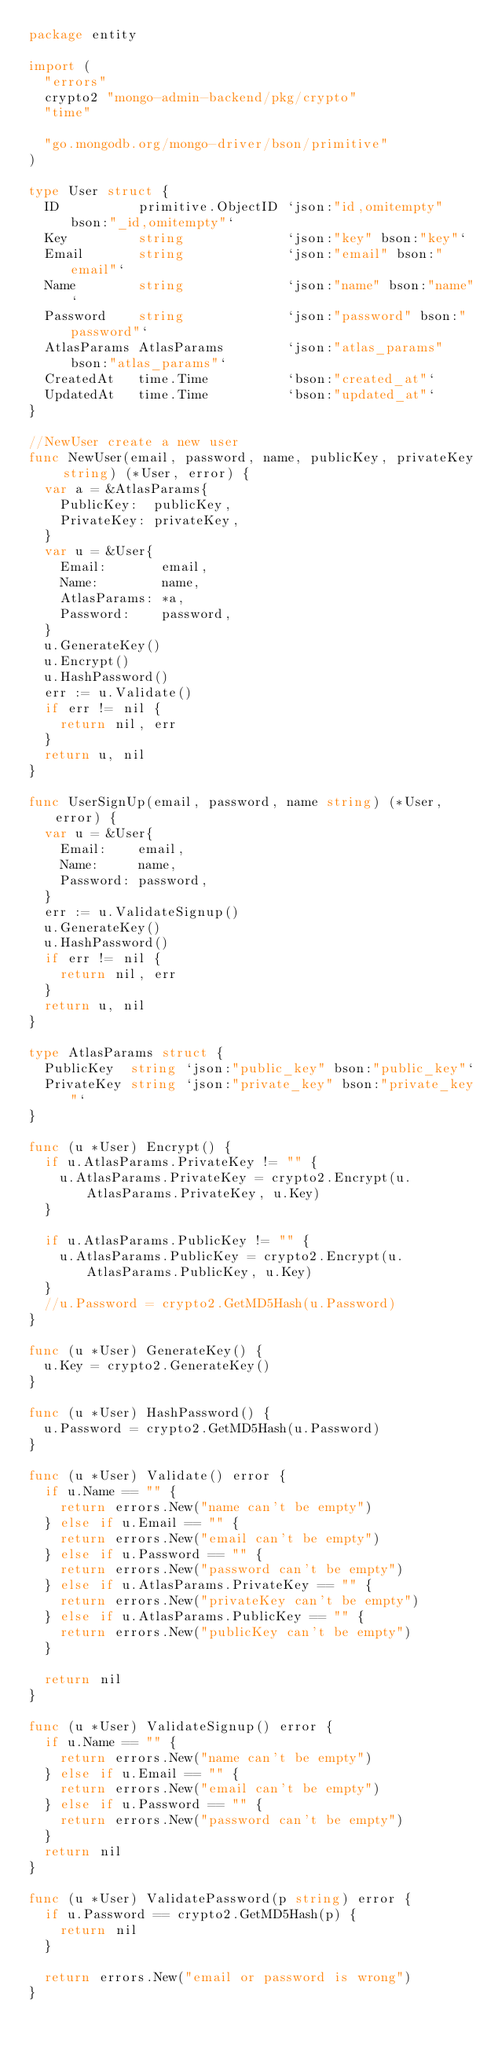<code> <loc_0><loc_0><loc_500><loc_500><_Go_>package entity

import (
	"errors"
	crypto2 "mongo-admin-backend/pkg/crypto"
	"time"

	"go.mongodb.org/mongo-driver/bson/primitive"
)

type User struct {
	ID          primitive.ObjectID `json:"id,omitempty" bson:"_id,omitempty"`
	Key         string             `json:"key" bson:"key"`
	Email       string             `json:"email" bson:"email"`
	Name        string             `json:"name" bson:"name"`
	Password    string             `json:"password" bson:"password"`
	AtlasParams AtlasParams        `json:"atlas_params" bson:"atlas_params"`
	CreatedAt   time.Time          `bson:"created_at"`
	UpdatedAt   time.Time          `bson:"updated_at"`
}

//NewUser create a new user
func NewUser(email, password, name, publicKey, privateKey string) (*User, error) {
	var a = &AtlasParams{
		PublicKey:  publicKey,
		PrivateKey: privateKey,
	}
	var u = &User{
		Email:       email,
		Name:        name,
		AtlasParams: *a,
		Password:    password,
	}
	u.GenerateKey()
	u.Encrypt()
	u.HashPassword()
	err := u.Validate()
	if err != nil {
		return nil, err
	}
	return u, nil
}

func UserSignUp(email, password, name string) (*User, error) {
	var u = &User{
		Email:    email,
		Name:     name,
		Password: password,
	}
	err := u.ValidateSignup()
	u.GenerateKey()
	u.HashPassword()
	if err != nil {
		return nil, err
	}
	return u, nil
}

type AtlasParams struct {
	PublicKey  string `json:"public_key" bson:"public_key"`
	PrivateKey string `json:"private_key" bson:"private_key"`
}

func (u *User) Encrypt() {
	if u.AtlasParams.PrivateKey != "" {
		u.AtlasParams.PrivateKey = crypto2.Encrypt(u.AtlasParams.PrivateKey, u.Key)
	}

	if u.AtlasParams.PublicKey != "" {
		u.AtlasParams.PublicKey = crypto2.Encrypt(u.AtlasParams.PublicKey, u.Key)
	}
	//u.Password = crypto2.GetMD5Hash(u.Password)
}

func (u *User) GenerateKey() {
	u.Key = crypto2.GenerateKey()
}

func (u *User) HashPassword() {
	u.Password = crypto2.GetMD5Hash(u.Password)
}

func (u *User) Validate() error {
	if u.Name == "" {
		return errors.New("name can't be empty")
	} else if u.Email == "" {
		return errors.New("email can't be empty")
	} else if u.Password == "" {
		return errors.New("password can't be empty")
	} else if u.AtlasParams.PrivateKey == "" {
		return errors.New("privateKey can't be empty")
	} else if u.AtlasParams.PublicKey == "" {
		return errors.New("publicKey can't be empty")
	}

	return nil
}

func (u *User) ValidateSignup() error {
	if u.Name == "" {
		return errors.New("name can't be empty")
	} else if u.Email == "" {
		return errors.New("email can't be empty")
	} else if u.Password == "" {
		return errors.New("password can't be empty")
	}
	return nil
}

func (u *User) ValidatePassword(p string) error {
	if u.Password == crypto2.GetMD5Hash(p) {
		return nil
	}

	return errors.New("email or password is wrong")
}
</code> 